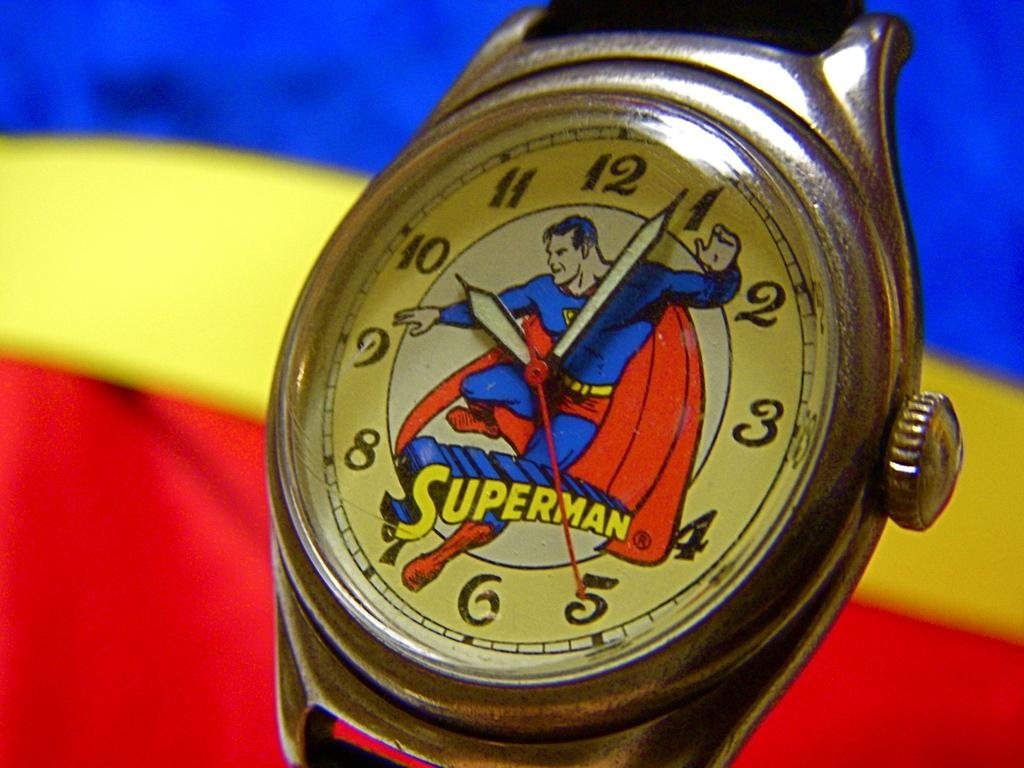<image>
Describe the image concisely. Wristwatch with a picture of Superman and the word as well. 